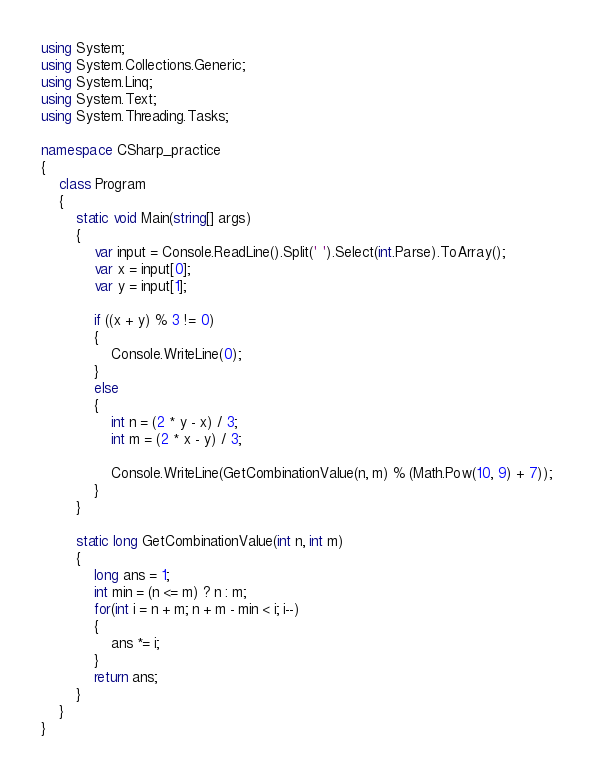Convert code to text. <code><loc_0><loc_0><loc_500><loc_500><_C#_>using System;
using System.Collections.Generic;
using System.Linq;
using System.Text;
using System.Threading.Tasks;

namespace CSharp_practice
{
    class Program
    {
        static void Main(string[] args)
        {
            var input = Console.ReadLine().Split(' ').Select(int.Parse).ToArray();
            var x = input[0];
            var y = input[1];

            if ((x + y) % 3 != 0)
            {
                Console.WriteLine(0);
            }
            else
            {
                int n = (2 * y - x) / 3;
                int m = (2 * x - y) / 3;

                Console.WriteLine(GetCombinationValue(n, m) % (Math.Pow(10, 9) + 7));
            }
        }

        static long GetCombinationValue(int n, int m)
        {
            long ans = 1;
            int min = (n <= m) ? n : m;
            for(int i = n + m; n + m - min < i; i--)
            {
                ans *= i;
            }
            return ans;
        }
    }
}
</code> 